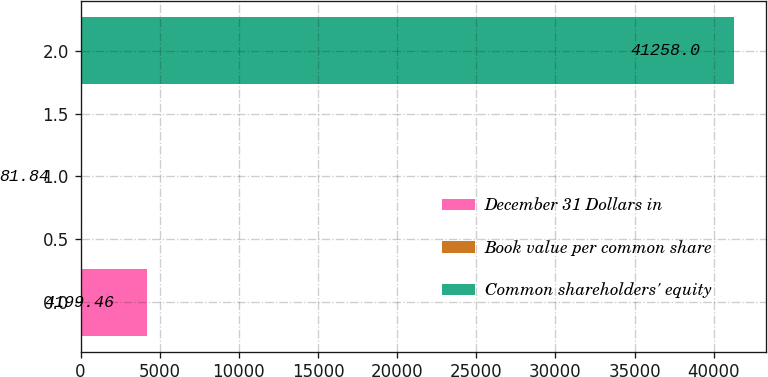Convert chart. <chart><loc_0><loc_0><loc_500><loc_500><bar_chart><fcel>December 31 Dollars in<fcel>Book value per common share<fcel>Common shareholders' equity<nl><fcel>4199.46<fcel>81.84<fcel>41258<nl></chart> 